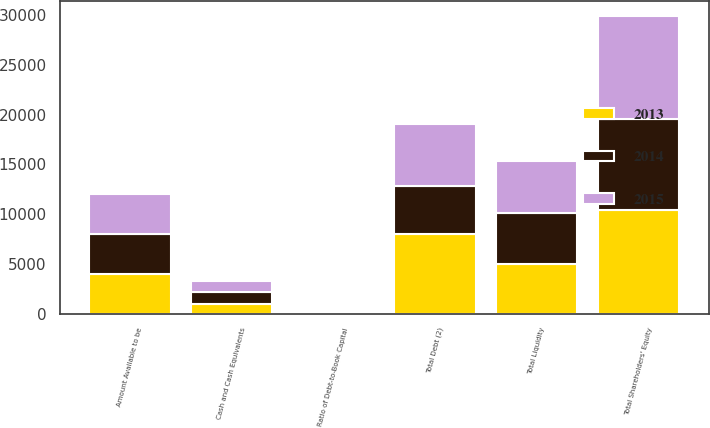Convert chart to OTSL. <chart><loc_0><loc_0><loc_500><loc_500><stacked_bar_chart><ecel><fcel>Cash and Cash Equivalents<fcel>Amount Available to be<fcel>Total Liquidity<fcel>Total Debt (2)<fcel>Total Shareholders' Equity<fcel>Ratio of Debt-to-Book Capital<nl><fcel>2013<fcel>1028<fcel>4000<fcel>5028<fcel>7976<fcel>10370<fcel>43<nl><fcel>2015<fcel>1183<fcel>4000<fcel>5183<fcel>6197<fcel>10325<fcel>38<nl><fcel>2014<fcel>1117<fcel>4000<fcel>5117<fcel>4843<fcel>9184<fcel>35<nl></chart> 